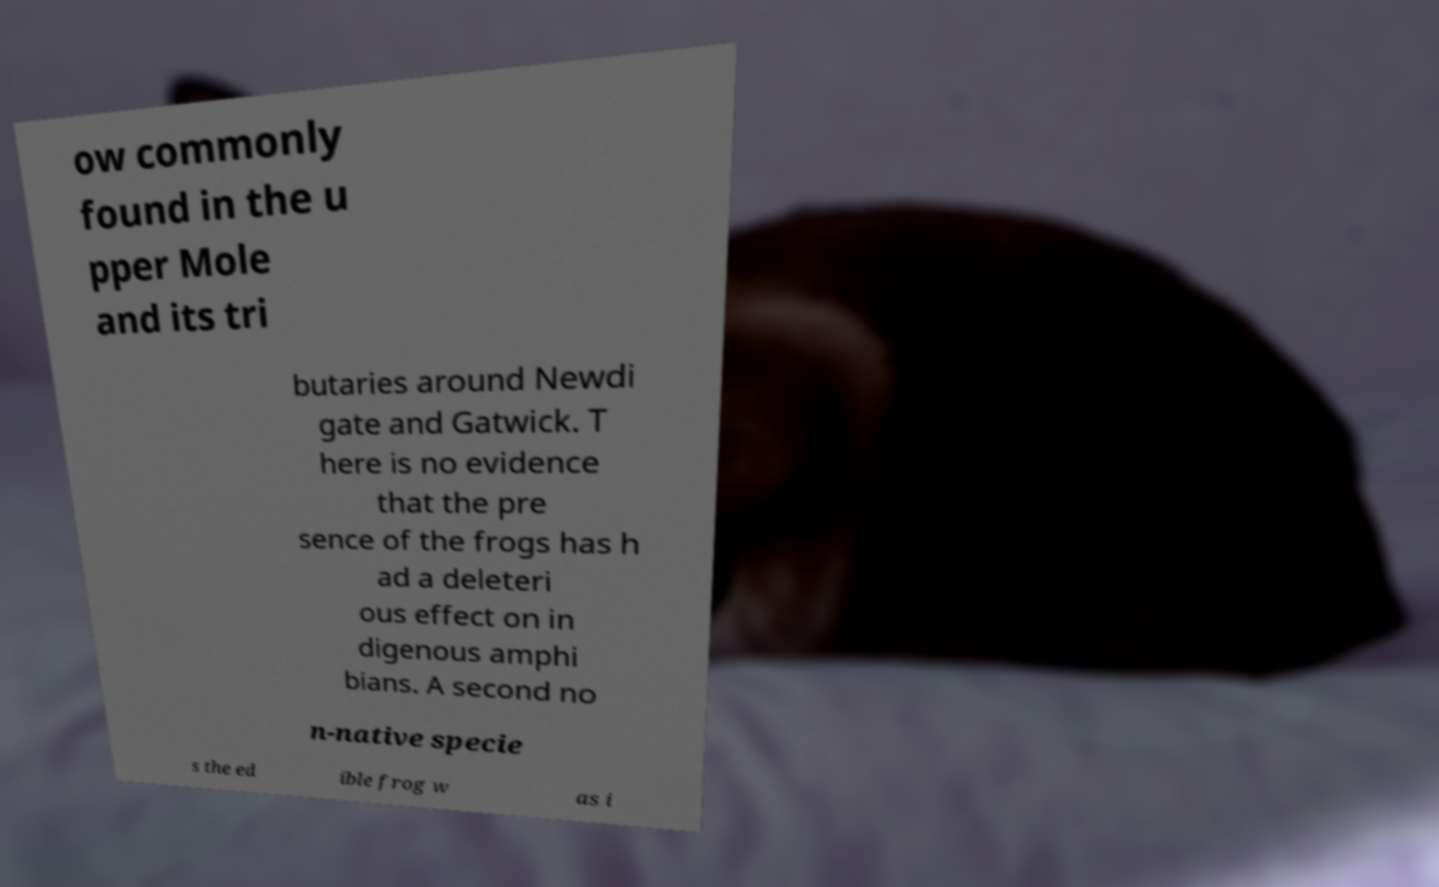Could you assist in decoding the text presented in this image and type it out clearly? ow commonly found in the u pper Mole and its tri butaries around Newdi gate and Gatwick. T here is no evidence that the pre sence of the frogs has h ad a deleteri ous effect on in digenous amphi bians. A second no n-native specie s the ed ible frog w as i 